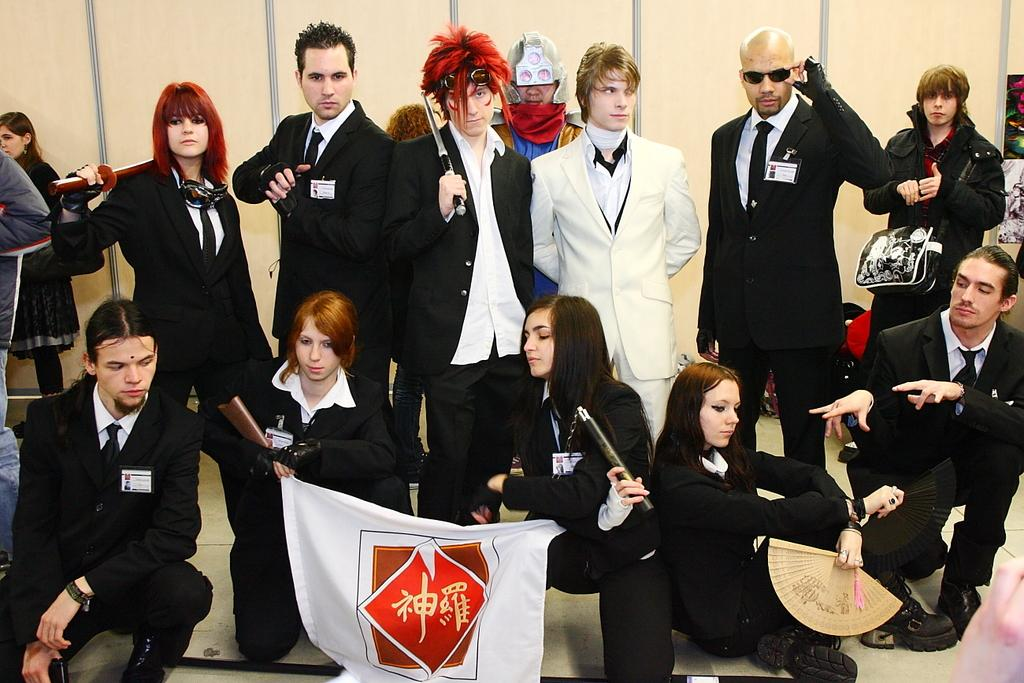What can be seen in the image regarding the people? There is a group of people in the image, and they are wearing black coats. What is the position of the people in the image? The people are standing. Can you describe the appearance of the guy in the image? The guy is wearing a white coat. How is the guy positioned in relation to the group of people? The guy is standing between the group of people. Can you see a dog in the image? There is no dog present in the image. 